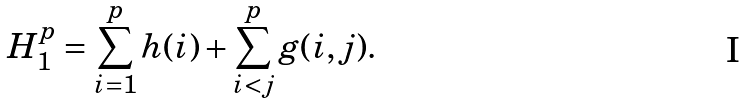Convert formula to latex. <formula><loc_0><loc_0><loc_500><loc_500>H _ { 1 } ^ { p } = \sum _ { i = 1 } ^ { p } h ( i ) + \sum _ { i < j } ^ { p } g ( i , j ) .</formula> 